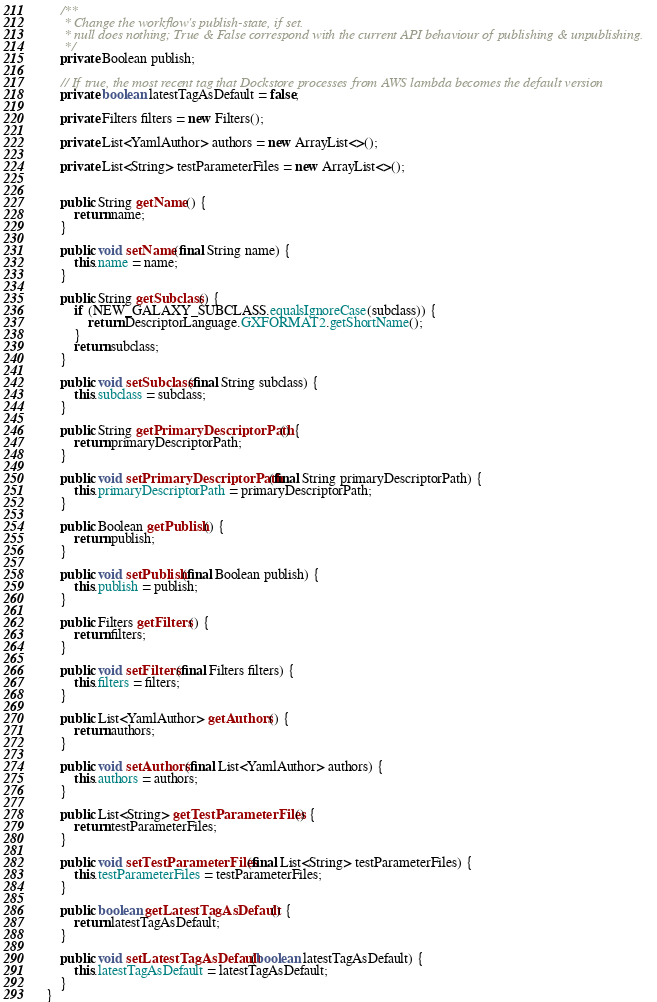Convert code to text. <code><loc_0><loc_0><loc_500><loc_500><_Java_>
    /**
     * Change the workflow's publish-state, if set.
     * null does nothing; True & False correspond with the current API behaviour of publishing & unpublishing.
     */
    private Boolean publish;

    // If true, the most recent tag that Dockstore processes from AWS lambda becomes the default version
    private boolean latestTagAsDefault = false;

    private Filters filters = new Filters();

    private List<YamlAuthor> authors = new ArrayList<>();

    private List<String> testParameterFiles = new ArrayList<>();


    public String getName() {
        return name;
    }

    public void setName(final String name) {
        this.name = name;
    }

    public String getSubclass() {
        if (NEW_GALAXY_SUBCLASS.equalsIgnoreCase(subclass)) {
            return DescriptorLanguage.GXFORMAT2.getShortName();
        }
        return subclass;
    }

    public void setSubclass(final String subclass) {
        this.subclass = subclass;
    }

    public String getPrimaryDescriptorPath() {
        return primaryDescriptorPath;
    }

    public void setPrimaryDescriptorPath(final String primaryDescriptorPath) {
        this.primaryDescriptorPath = primaryDescriptorPath;
    }

    public Boolean getPublish() {
        return publish;
    }

    public void setPublish(final Boolean publish) {
        this.publish = publish;
    }

    public Filters getFilters() {
        return filters;
    }

    public void setFilters(final Filters filters) {
        this.filters = filters;
    }

    public List<YamlAuthor> getAuthors() {
        return authors;
    }

    public void setAuthors(final List<YamlAuthor> authors) {
        this.authors = authors;
    }

    public List<String> getTestParameterFiles() {
        return testParameterFiles;
    }

    public void setTestParameterFiles(final List<String> testParameterFiles) {
        this.testParameterFiles = testParameterFiles;
    }

    public boolean getLatestTagAsDefault() {
        return latestTagAsDefault;
    }

    public void setLatestTagAsDefault(boolean latestTagAsDefault) {
        this.latestTagAsDefault = latestTagAsDefault;
    }
}
</code> 